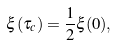Convert formula to latex. <formula><loc_0><loc_0><loc_500><loc_500>\xi ( \tau _ { c } ) = \frac { 1 } { 2 } \xi ( 0 ) ,</formula> 